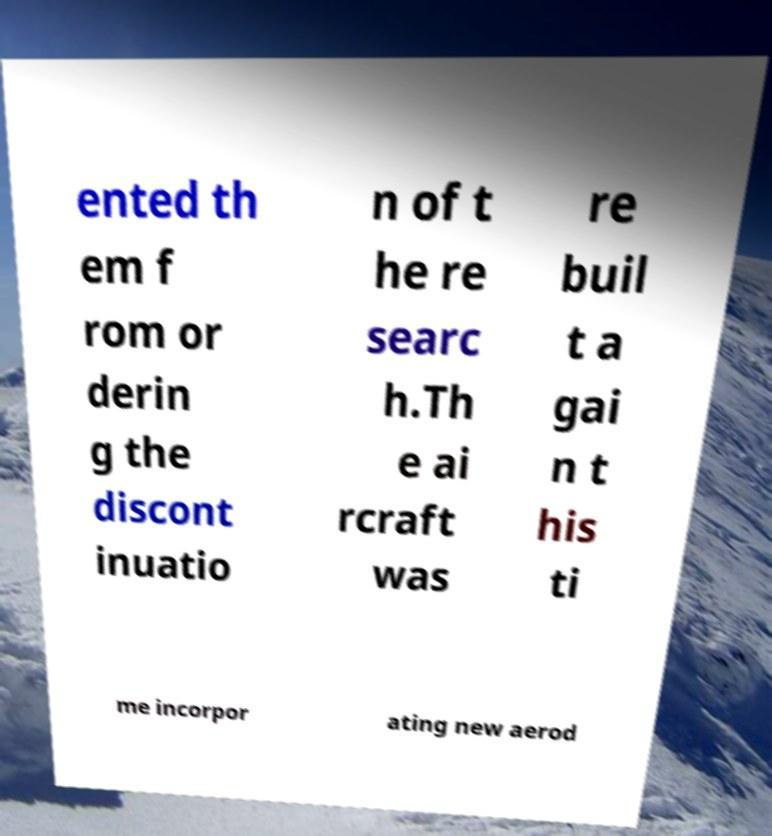Can you accurately transcribe the text from the provided image for me? ented th em f rom or derin g the discont inuatio n of t he re searc h.Th e ai rcraft was re buil t a gai n t his ti me incorpor ating new aerod 